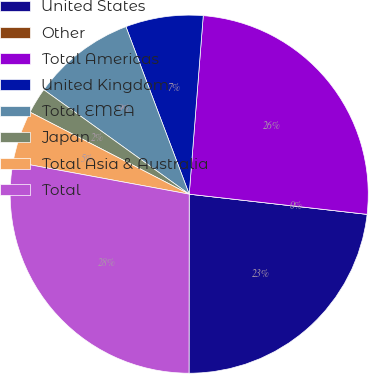Convert chart to OTSL. <chart><loc_0><loc_0><loc_500><loc_500><pie_chart><fcel>United States<fcel>Other<fcel>Total Americas<fcel>United Kingdom<fcel>Total EMEA<fcel>Japan<fcel>Total Asia & Australia<fcel>Total<nl><fcel>23.22%<fcel>0.0%<fcel>25.55%<fcel>7.0%<fcel>9.34%<fcel>2.34%<fcel>4.67%<fcel>27.89%<nl></chart> 